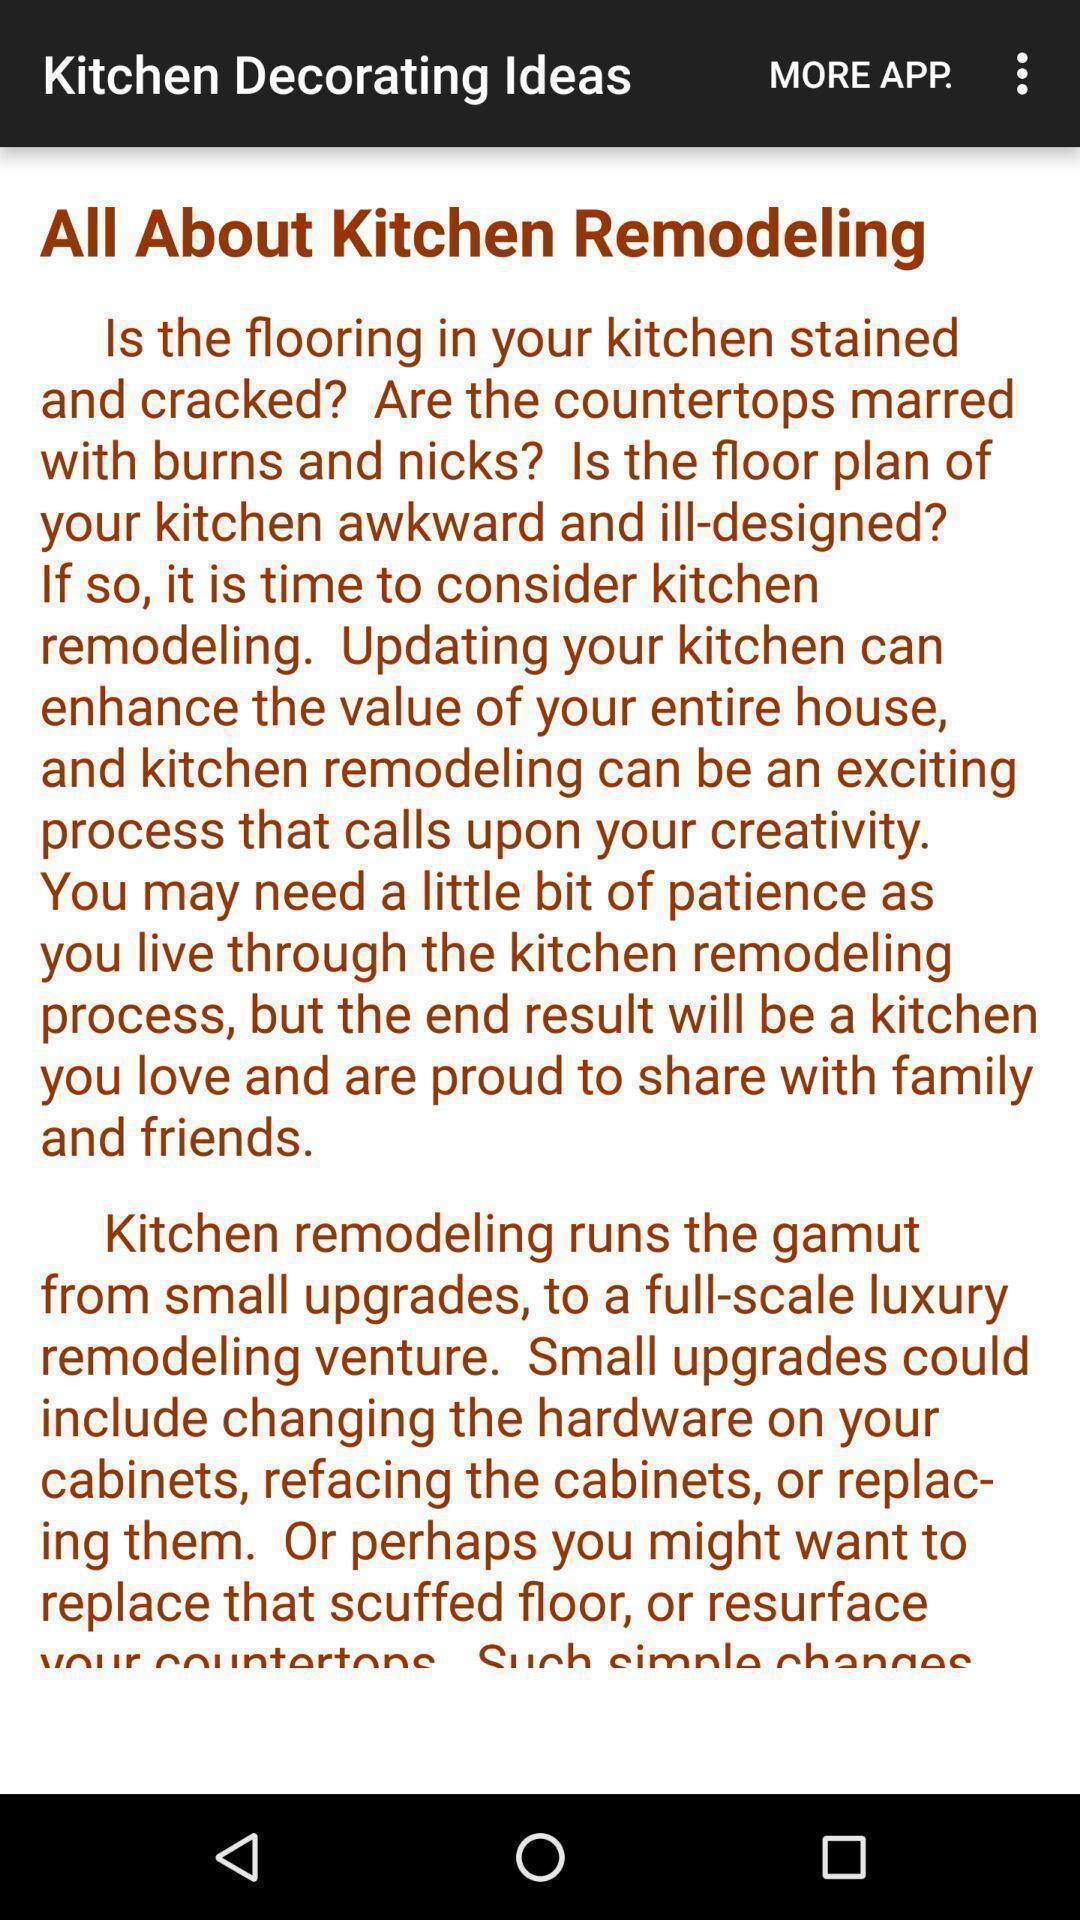Summarize the information in this screenshot. Page showing an article. 